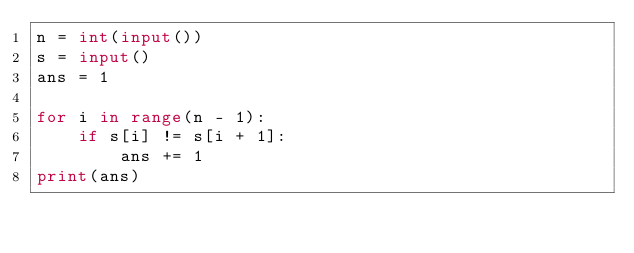Convert code to text. <code><loc_0><loc_0><loc_500><loc_500><_Python_>n = int(input())
s = input()
ans = 1

for i in range(n - 1):
    if s[i] != s[i + 1]:
        ans += 1
print(ans)
</code> 